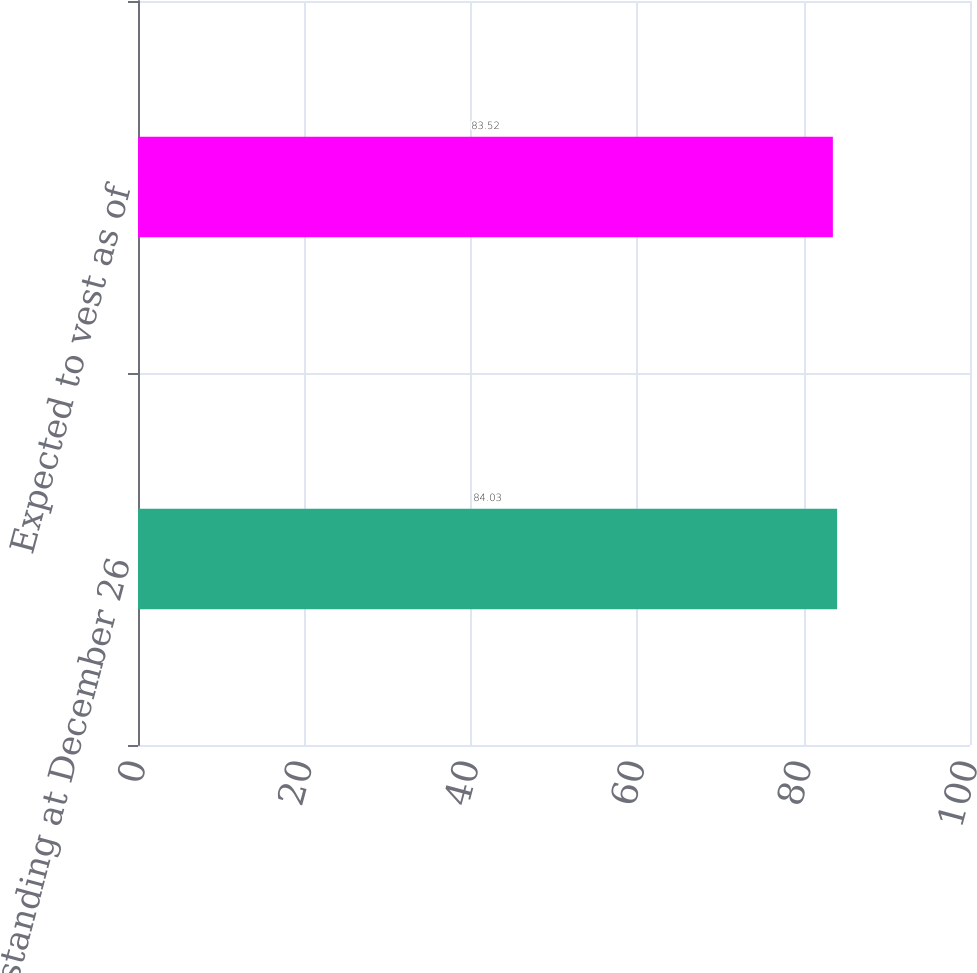<chart> <loc_0><loc_0><loc_500><loc_500><bar_chart><fcel>Outstanding at December 26<fcel>Expected to vest as of<nl><fcel>84.03<fcel>83.52<nl></chart> 